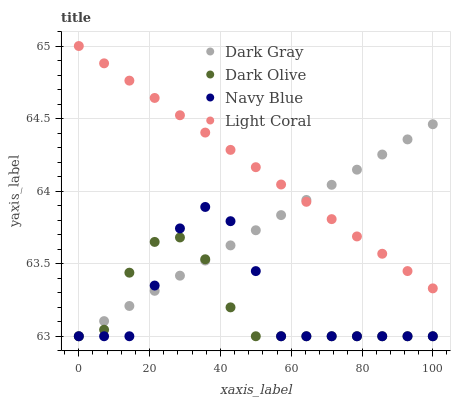Does Dark Olive have the minimum area under the curve?
Answer yes or no. Yes. Does Light Coral have the maximum area under the curve?
Answer yes or no. Yes. Does Navy Blue have the minimum area under the curve?
Answer yes or no. No. Does Navy Blue have the maximum area under the curve?
Answer yes or no. No. Is Light Coral the smoothest?
Answer yes or no. Yes. Is Navy Blue the roughest?
Answer yes or no. Yes. Is Dark Olive the smoothest?
Answer yes or no. No. Is Dark Olive the roughest?
Answer yes or no. No. Does Dark Gray have the lowest value?
Answer yes or no. Yes. Does Light Coral have the lowest value?
Answer yes or no. No. Does Light Coral have the highest value?
Answer yes or no. Yes. Does Navy Blue have the highest value?
Answer yes or no. No. Is Dark Olive less than Light Coral?
Answer yes or no. Yes. Is Light Coral greater than Dark Olive?
Answer yes or no. Yes. Does Dark Gray intersect Navy Blue?
Answer yes or no. Yes. Is Dark Gray less than Navy Blue?
Answer yes or no. No. Is Dark Gray greater than Navy Blue?
Answer yes or no. No. Does Dark Olive intersect Light Coral?
Answer yes or no. No. 